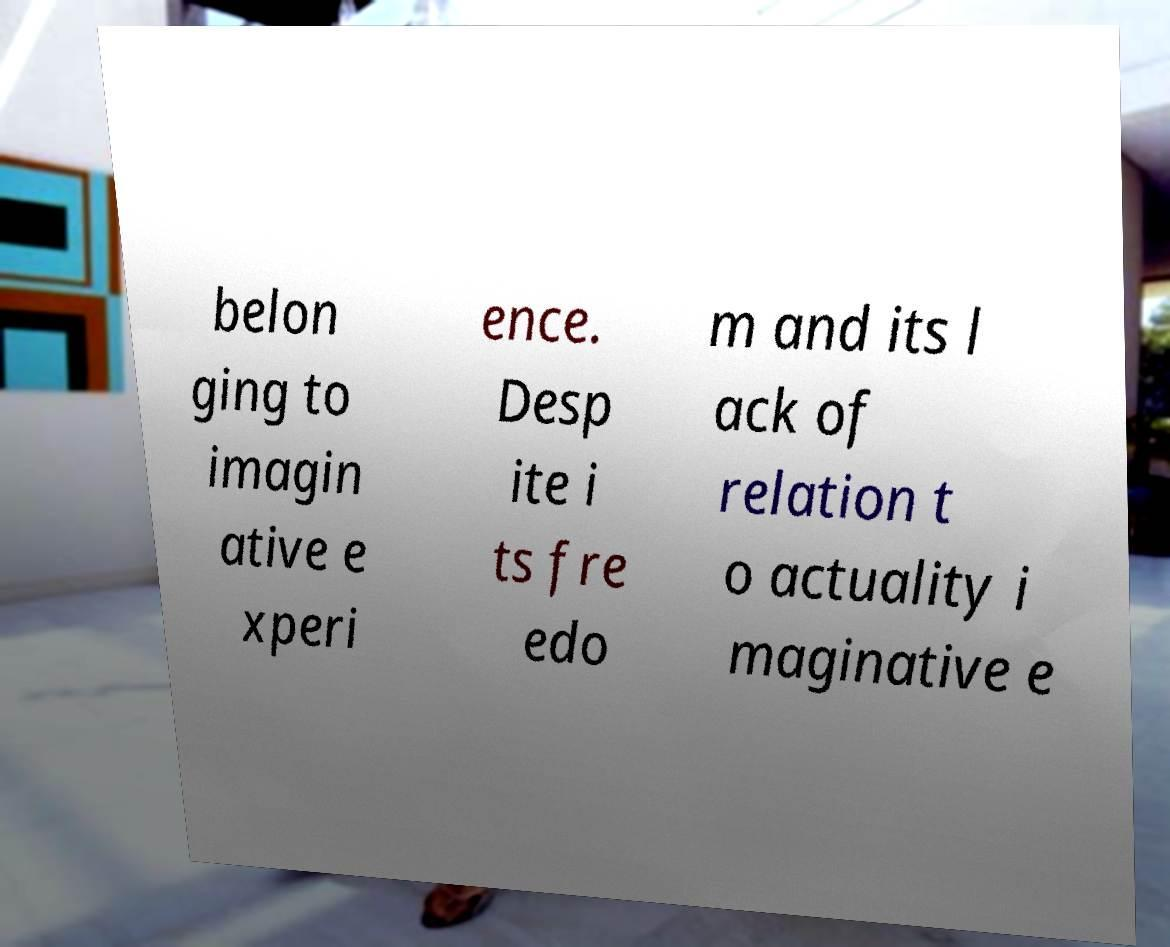Please identify and transcribe the text found in this image. belon ging to imagin ative e xperi ence. Desp ite i ts fre edo m and its l ack of relation t o actuality i maginative e 